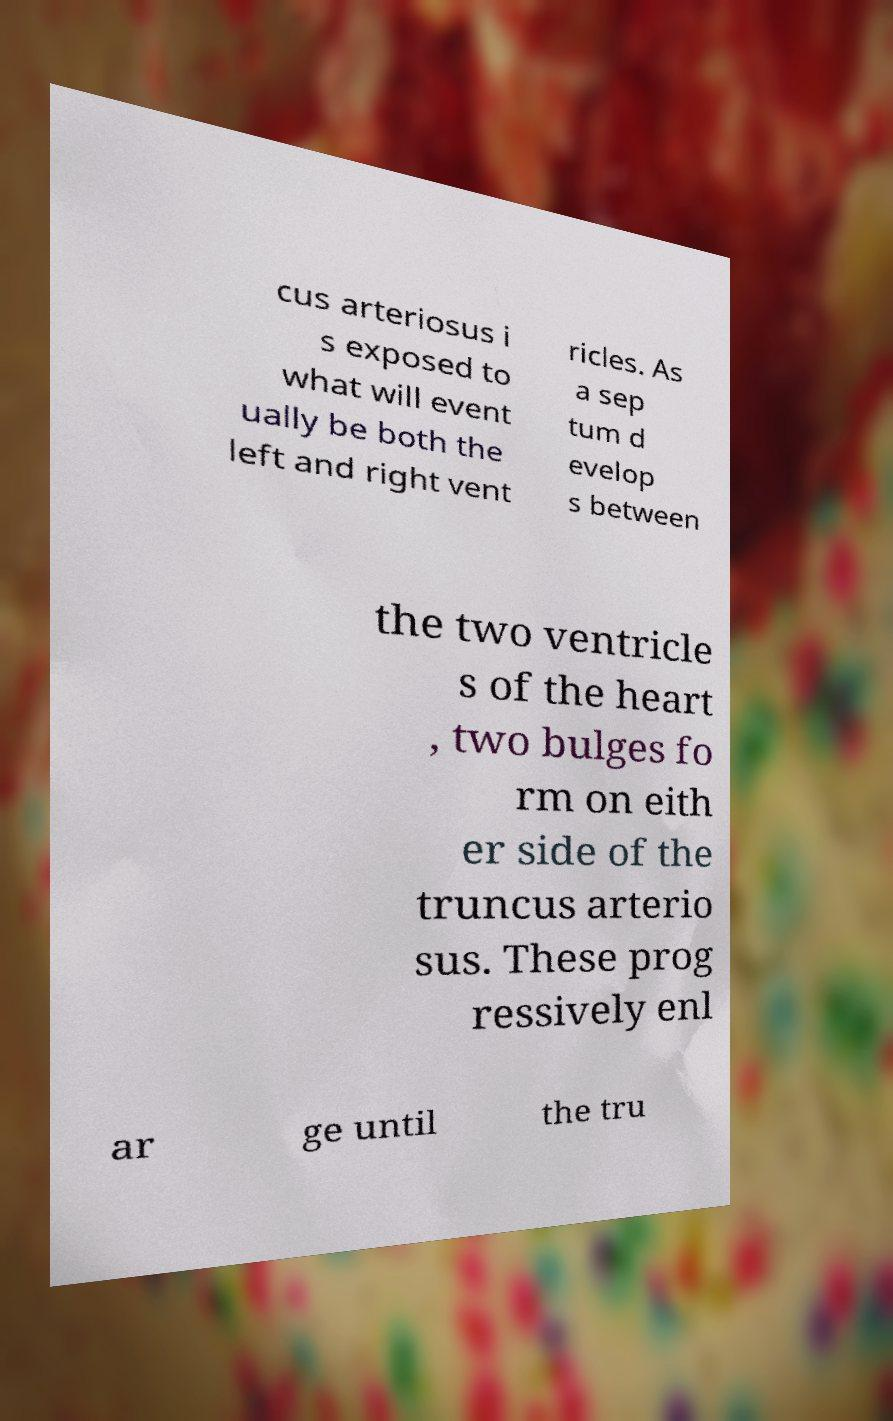I need the written content from this picture converted into text. Can you do that? cus arteriosus i s exposed to what will event ually be both the left and right vent ricles. As a sep tum d evelop s between the two ventricle s of the heart , two bulges fo rm on eith er side of the truncus arterio sus. These prog ressively enl ar ge until the tru 